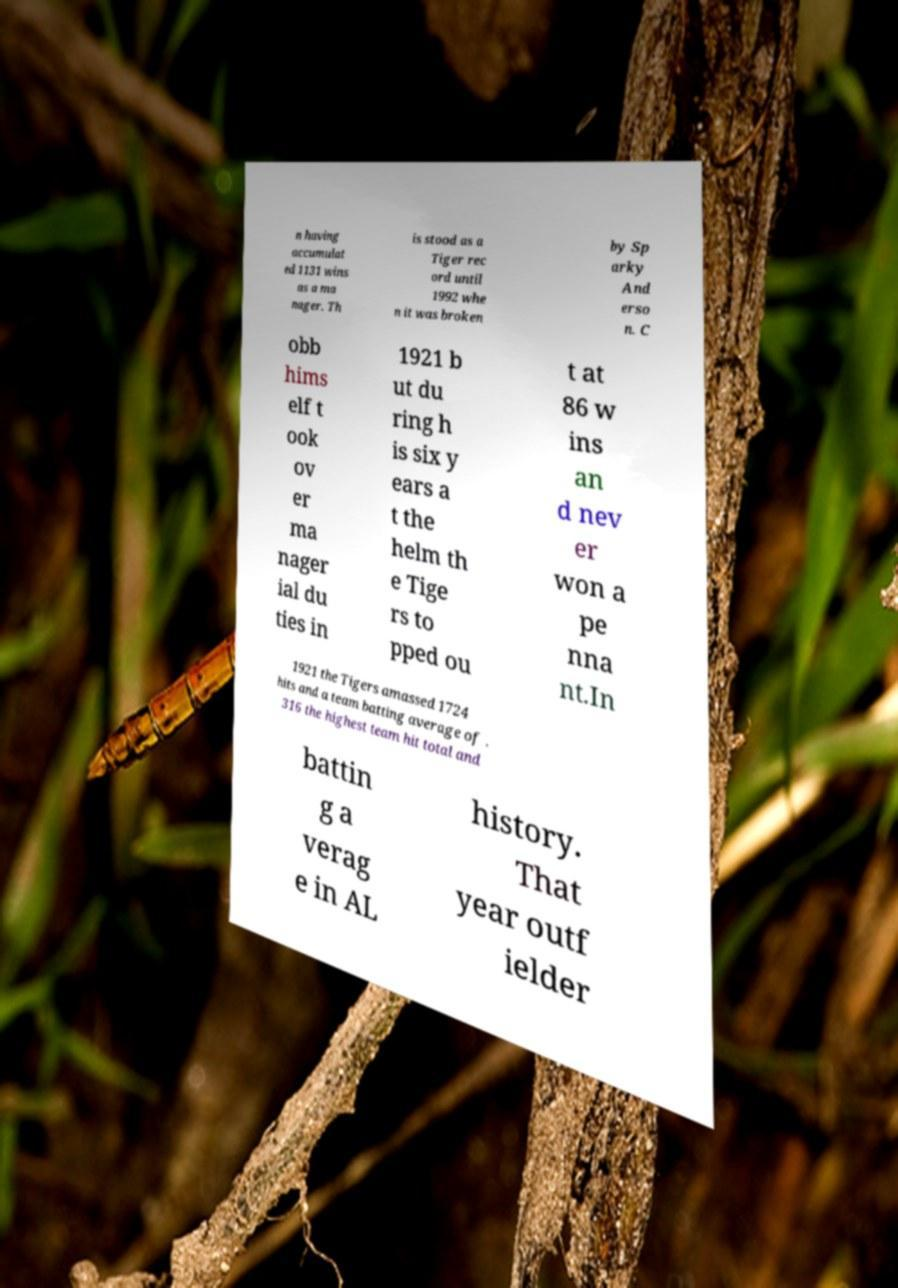I need the written content from this picture converted into text. Can you do that? n having accumulat ed 1131 wins as a ma nager. Th is stood as a Tiger rec ord until 1992 whe n it was broken by Sp arky And erso n. C obb hims elf t ook ov er ma nager ial du ties in 1921 b ut du ring h is six y ears a t the helm th e Tige rs to pped ou t at 86 w ins an d nev er won a pe nna nt.In 1921 the Tigers amassed 1724 hits and a team batting average of . 316 the highest team hit total and battin g a verag e in AL history. That year outf ielder 